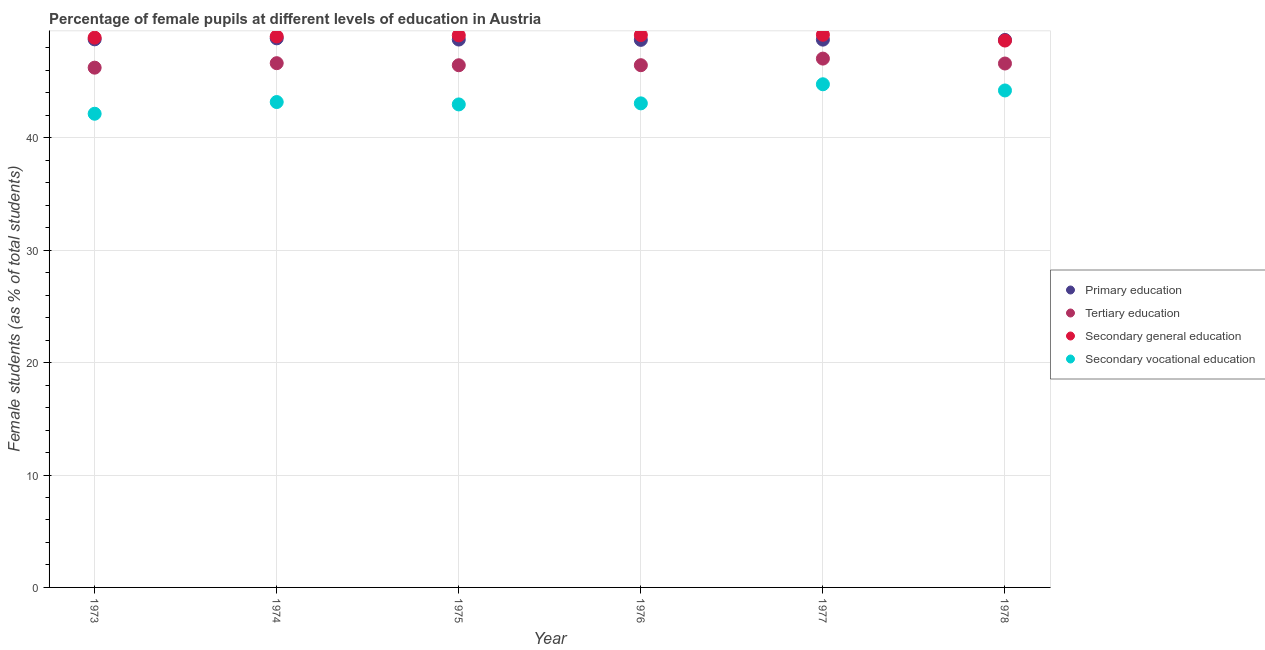How many different coloured dotlines are there?
Offer a very short reply. 4. Is the number of dotlines equal to the number of legend labels?
Your answer should be very brief. Yes. What is the percentage of female students in secondary education in 1975?
Provide a succinct answer. 49.11. Across all years, what is the maximum percentage of female students in secondary vocational education?
Provide a succinct answer. 44.76. Across all years, what is the minimum percentage of female students in secondary education?
Offer a very short reply. 48.65. In which year was the percentage of female students in primary education minimum?
Offer a very short reply. 1978. What is the total percentage of female students in tertiary education in the graph?
Offer a very short reply. 279.45. What is the difference between the percentage of female students in secondary vocational education in 1975 and that in 1977?
Ensure brevity in your answer.  -1.79. What is the difference between the percentage of female students in primary education in 1976 and the percentage of female students in secondary vocational education in 1977?
Provide a short and direct response. 3.95. What is the average percentage of female students in secondary vocational education per year?
Offer a very short reply. 43.39. In the year 1973, what is the difference between the percentage of female students in tertiary education and percentage of female students in primary education?
Keep it short and to the point. -2.52. What is the ratio of the percentage of female students in secondary education in 1973 to that in 1976?
Offer a terse response. 1. What is the difference between the highest and the second highest percentage of female students in secondary vocational education?
Provide a short and direct response. 0.55. What is the difference between the highest and the lowest percentage of female students in primary education?
Offer a terse response. 0.14. Is the sum of the percentage of female students in secondary education in 1974 and 1978 greater than the maximum percentage of female students in tertiary education across all years?
Keep it short and to the point. Yes. Is it the case that in every year, the sum of the percentage of female students in secondary vocational education and percentage of female students in secondary education is greater than the sum of percentage of female students in primary education and percentage of female students in tertiary education?
Make the answer very short. No. Is the percentage of female students in tertiary education strictly greater than the percentage of female students in primary education over the years?
Your answer should be compact. No. Is the percentage of female students in tertiary education strictly less than the percentage of female students in secondary education over the years?
Keep it short and to the point. Yes. How many years are there in the graph?
Your answer should be compact. 6. What is the difference between two consecutive major ticks on the Y-axis?
Your answer should be compact. 10. Are the values on the major ticks of Y-axis written in scientific E-notation?
Your answer should be very brief. No. Does the graph contain any zero values?
Give a very brief answer. No. Where does the legend appear in the graph?
Your answer should be very brief. Center right. How many legend labels are there?
Ensure brevity in your answer.  4. How are the legend labels stacked?
Give a very brief answer. Vertical. What is the title of the graph?
Keep it short and to the point. Percentage of female pupils at different levels of education in Austria. Does "Burnt food" appear as one of the legend labels in the graph?
Provide a succinct answer. No. What is the label or title of the X-axis?
Make the answer very short. Year. What is the label or title of the Y-axis?
Make the answer very short. Female students (as % of total students). What is the Female students (as % of total students) in Primary education in 1973?
Your answer should be compact. 48.76. What is the Female students (as % of total students) in Tertiary education in 1973?
Ensure brevity in your answer.  46.24. What is the Female students (as % of total students) in Secondary general education in 1973?
Your answer should be very brief. 48.91. What is the Female students (as % of total students) of Secondary vocational education in 1973?
Provide a short and direct response. 42.14. What is the Female students (as % of total students) of Primary education in 1974?
Your answer should be compact. 48.85. What is the Female students (as % of total students) in Tertiary education in 1974?
Provide a short and direct response. 46.64. What is the Female students (as % of total students) of Secondary general education in 1974?
Your answer should be compact. 49.02. What is the Female students (as % of total students) of Secondary vocational education in 1974?
Provide a succinct answer. 43.18. What is the Female students (as % of total students) of Primary education in 1975?
Make the answer very short. 48.74. What is the Female students (as % of total students) of Tertiary education in 1975?
Your response must be concise. 46.46. What is the Female students (as % of total students) of Secondary general education in 1975?
Your answer should be very brief. 49.11. What is the Female students (as % of total students) of Secondary vocational education in 1975?
Make the answer very short. 42.97. What is the Female students (as % of total students) of Primary education in 1976?
Offer a very short reply. 48.71. What is the Female students (as % of total students) in Tertiary education in 1976?
Make the answer very short. 46.46. What is the Female students (as % of total students) of Secondary general education in 1976?
Your response must be concise. 49.14. What is the Female students (as % of total students) of Secondary vocational education in 1976?
Make the answer very short. 43.06. What is the Female students (as % of total students) of Primary education in 1977?
Provide a succinct answer. 48.73. What is the Female students (as % of total students) in Tertiary education in 1977?
Your answer should be very brief. 47.05. What is the Female students (as % of total students) in Secondary general education in 1977?
Offer a terse response. 49.17. What is the Female students (as % of total students) of Secondary vocational education in 1977?
Offer a terse response. 44.76. What is the Female students (as % of total students) in Primary education in 1978?
Your answer should be compact. 48.71. What is the Female students (as % of total students) in Tertiary education in 1978?
Your response must be concise. 46.61. What is the Female students (as % of total students) in Secondary general education in 1978?
Give a very brief answer. 48.65. What is the Female students (as % of total students) of Secondary vocational education in 1978?
Make the answer very short. 44.21. Across all years, what is the maximum Female students (as % of total students) in Primary education?
Keep it short and to the point. 48.85. Across all years, what is the maximum Female students (as % of total students) in Tertiary education?
Ensure brevity in your answer.  47.05. Across all years, what is the maximum Female students (as % of total students) in Secondary general education?
Your answer should be compact. 49.17. Across all years, what is the maximum Female students (as % of total students) of Secondary vocational education?
Your response must be concise. 44.76. Across all years, what is the minimum Female students (as % of total students) of Primary education?
Your response must be concise. 48.71. Across all years, what is the minimum Female students (as % of total students) in Tertiary education?
Ensure brevity in your answer.  46.24. Across all years, what is the minimum Female students (as % of total students) in Secondary general education?
Your response must be concise. 48.65. Across all years, what is the minimum Female students (as % of total students) in Secondary vocational education?
Give a very brief answer. 42.14. What is the total Female students (as % of total students) in Primary education in the graph?
Offer a very short reply. 292.51. What is the total Female students (as % of total students) of Tertiary education in the graph?
Offer a very short reply. 279.45. What is the total Female students (as % of total students) in Secondary general education in the graph?
Your answer should be very brief. 294. What is the total Female students (as % of total students) in Secondary vocational education in the graph?
Your answer should be compact. 260.33. What is the difference between the Female students (as % of total students) in Primary education in 1973 and that in 1974?
Give a very brief answer. -0.09. What is the difference between the Female students (as % of total students) in Tertiary education in 1973 and that in 1974?
Your response must be concise. -0.4. What is the difference between the Female students (as % of total students) of Secondary general education in 1973 and that in 1974?
Your answer should be compact. -0.11. What is the difference between the Female students (as % of total students) in Secondary vocational education in 1973 and that in 1974?
Make the answer very short. -1.04. What is the difference between the Female students (as % of total students) in Primary education in 1973 and that in 1975?
Your answer should be compact. 0.02. What is the difference between the Female students (as % of total students) of Tertiary education in 1973 and that in 1975?
Your response must be concise. -0.22. What is the difference between the Female students (as % of total students) of Secondary general education in 1973 and that in 1975?
Ensure brevity in your answer.  -0.2. What is the difference between the Female students (as % of total students) of Secondary vocational education in 1973 and that in 1975?
Provide a short and direct response. -0.83. What is the difference between the Female students (as % of total students) of Primary education in 1973 and that in 1976?
Give a very brief answer. 0.05. What is the difference between the Female students (as % of total students) in Tertiary education in 1973 and that in 1976?
Offer a terse response. -0.22. What is the difference between the Female students (as % of total students) of Secondary general education in 1973 and that in 1976?
Your answer should be compact. -0.23. What is the difference between the Female students (as % of total students) in Secondary vocational education in 1973 and that in 1976?
Offer a terse response. -0.92. What is the difference between the Female students (as % of total students) of Primary education in 1973 and that in 1977?
Your answer should be very brief. 0.03. What is the difference between the Female students (as % of total students) in Tertiary education in 1973 and that in 1977?
Offer a very short reply. -0.81. What is the difference between the Female students (as % of total students) of Secondary general education in 1973 and that in 1977?
Ensure brevity in your answer.  -0.26. What is the difference between the Female students (as % of total students) in Secondary vocational education in 1973 and that in 1977?
Provide a succinct answer. -2.62. What is the difference between the Female students (as % of total students) of Primary education in 1973 and that in 1978?
Your answer should be very brief. 0.05. What is the difference between the Female students (as % of total students) of Tertiary education in 1973 and that in 1978?
Your response must be concise. -0.37. What is the difference between the Female students (as % of total students) of Secondary general education in 1973 and that in 1978?
Your answer should be compact. 0.26. What is the difference between the Female students (as % of total students) in Secondary vocational education in 1973 and that in 1978?
Provide a short and direct response. -2.07. What is the difference between the Female students (as % of total students) of Primary education in 1974 and that in 1975?
Keep it short and to the point. 0.11. What is the difference between the Female students (as % of total students) of Tertiary education in 1974 and that in 1975?
Your answer should be very brief. 0.18. What is the difference between the Female students (as % of total students) of Secondary general education in 1974 and that in 1975?
Your answer should be compact. -0.1. What is the difference between the Female students (as % of total students) of Secondary vocational education in 1974 and that in 1975?
Keep it short and to the point. 0.21. What is the difference between the Female students (as % of total students) of Primary education in 1974 and that in 1976?
Your answer should be very brief. 0.14. What is the difference between the Female students (as % of total students) of Tertiary education in 1974 and that in 1976?
Your answer should be compact. 0.18. What is the difference between the Female students (as % of total students) of Secondary general education in 1974 and that in 1976?
Your response must be concise. -0.12. What is the difference between the Female students (as % of total students) in Secondary vocational education in 1974 and that in 1976?
Provide a succinct answer. 0.12. What is the difference between the Female students (as % of total students) in Primary education in 1974 and that in 1977?
Keep it short and to the point. 0.12. What is the difference between the Female students (as % of total students) in Tertiary education in 1974 and that in 1977?
Keep it short and to the point. -0.41. What is the difference between the Female students (as % of total students) of Secondary general education in 1974 and that in 1977?
Give a very brief answer. -0.15. What is the difference between the Female students (as % of total students) of Secondary vocational education in 1974 and that in 1977?
Provide a short and direct response. -1.58. What is the difference between the Female students (as % of total students) of Primary education in 1974 and that in 1978?
Give a very brief answer. 0.14. What is the difference between the Female students (as % of total students) in Tertiary education in 1974 and that in 1978?
Provide a succinct answer. 0.03. What is the difference between the Female students (as % of total students) in Secondary general education in 1974 and that in 1978?
Provide a short and direct response. 0.36. What is the difference between the Female students (as % of total students) in Secondary vocational education in 1974 and that in 1978?
Your response must be concise. -1.03. What is the difference between the Female students (as % of total students) of Primary education in 1975 and that in 1976?
Keep it short and to the point. 0.03. What is the difference between the Female students (as % of total students) of Tertiary education in 1975 and that in 1976?
Your answer should be very brief. -0. What is the difference between the Female students (as % of total students) in Secondary general education in 1975 and that in 1976?
Offer a very short reply. -0.03. What is the difference between the Female students (as % of total students) in Secondary vocational education in 1975 and that in 1976?
Make the answer very short. -0.09. What is the difference between the Female students (as % of total students) in Primary education in 1975 and that in 1977?
Make the answer very short. 0.01. What is the difference between the Female students (as % of total students) in Tertiary education in 1975 and that in 1977?
Your answer should be very brief. -0.59. What is the difference between the Female students (as % of total students) in Secondary general education in 1975 and that in 1977?
Provide a short and direct response. -0.05. What is the difference between the Female students (as % of total students) in Secondary vocational education in 1975 and that in 1977?
Offer a terse response. -1.79. What is the difference between the Female students (as % of total students) of Primary education in 1975 and that in 1978?
Your answer should be compact. 0.03. What is the difference between the Female students (as % of total students) of Tertiary education in 1975 and that in 1978?
Offer a very short reply. -0.15. What is the difference between the Female students (as % of total students) of Secondary general education in 1975 and that in 1978?
Your response must be concise. 0.46. What is the difference between the Female students (as % of total students) in Secondary vocational education in 1975 and that in 1978?
Keep it short and to the point. -1.24. What is the difference between the Female students (as % of total students) of Primary education in 1976 and that in 1977?
Offer a terse response. -0.02. What is the difference between the Female students (as % of total students) in Tertiary education in 1976 and that in 1977?
Offer a terse response. -0.59. What is the difference between the Female students (as % of total students) in Secondary general education in 1976 and that in 1977?
Your answer should be very brief. -0.03. What is the difference between the Female students (as % of total students) of Secondary vocational education in 1976 and that in 1977?
Provide a short and direct response. -1.7. What is the difference between the Female students (as % of total students) in Primary education in 1976 and that in 1978?
Offer a terse response. 0.01. What is the difference between the Female students (as % of total students) of Tertiary education in 1976 and that in 1978?
Make the answer very short. -0.15. What is the difference between the Female students (as % of total students) of Secondary general education in 1976 and that in 1978?
Your response must be concise. 0.49. What is the difference between the Female students (as % of total students) in Secondary vocational education in 1976 and that in 1978?
Your answer should be very brief. -1.15. What is the difference between the Female students (as % of total students) in Primary education in 1977 and that in 1978?
Your answer should be very brief. 0.03. What is the difference between the Female students (as % of total students) of Tertiary education in 1977 and that in 1978?
Your answer should be compact. 0.44. What is the difference between the Female students (as % of total students) of Secondary general education in 1977 and that in 1978?
Offer a very short reply. 0.51. What is the difference between the Female students (as % of total students) of Secondary vocational education in 1977 and that in 1978?
Your response must be concise. 0.55. What is the difference between the Female students (as % of total students) of Primary education in 1973 and the Female students (as % of total students) of Tertiary education in 1974?
Ensure brevity in your answer.  2.12. What is the difference between the Female students (as % of total students) of Primary education in 1973 and the Female students (as % of total students) of Secondary general education in 1974?
Provide a succinct answer. -0.25. What is the difference between the Female students (as % of total students) of Primary education in 1973 and the Female students (as % of total students) of Secondary vocational education in 1974?
Your answer should be compact. 5.58. What is the difference between the Female students (as % of total students) in Tertiary education in 1973 and the Female students (as % of total students) in Secondary general education in 1974?
Offer a terse response. -2.77. What is the difference between the Female students (as % of total students) of Tertiary education in 1973 and the Female students (as % of total students) of Secondary vocational education in 1974?
Offer a terse response. 3.06. What is the difference between the Female students (as % of total students) of Secondary general education in 1973 and the Female students (as % of total students) of Secondary vocational education in 1974?
Provide a short and direct response. 5.73. What is the difference between the Female students (as % of total students) in Primary education in 1973 and the Female students (as % of total students) in Tertiary education in 1975?
Offer a terse response. 2.3. What is the difference between the Female students (as % of total students) in Primary education in 1973 and the Female students (as % of total students) in Secondary general education in 1975?
Make the answer very short. -0.35. What is the difference between the Female students (as % of total students) in Primary education in 1973 and the Female students (as % of total students) in Secondary vocational education in 1975?
Your answer should be compact. 5.79. What is the difference between the Female students (as % of total students) of Tertiary education in 1973 and the Female students (as % of total students) of Secondary general education in 1975?
Offer a terse response. -2.87. What is the difference between the Female students (as % of total students) in Tertiary education in 1973 and the Female students (as % of total students) in Secondary vocational education in 1975?
Ensure brevity in your answer.  3.27. What is the difference between the Female students (as % of total students) in Secondary general education in 1973 and the Female students (as % of total students) in Secondary vocational education in 1975?
Ensure brevity in your answer.  5.94. What is the difference between the Female students (as % of total students) of Primary education in 1973 and the Female students (as % of total students) of Tertiary education in 1976?
Give a very brief answer. 2.3. What is the difference between the Female students (as % of total students) in Primary education in 1973 and the Female students (as % of total students) in Secondary general education in 1976?
Ensure brevity in your answer.  -0.38. What is the difference between the Female students (as % of total students) in Primary education in 1973 and the Female students (as % of total students) in Secondary vocational education in 1976?
Offer a very short reply. 5.7. What is the difference between the Female students (as % of total students) in Tertiary education in 1973 and the Female students (as % of total students) in Secondary general education in 1976?
Your answer should be compact. -2.9. What is the difference between the Female students (as % of total students) of Tertiary education in 1973 and the Female students (as % of total students) of Secondary vocational education in 1976?
Your answer should be compact. 3.18. What is the difference between the Female students (as % of total students) in Secondary general education in 1973 and the Female students (as % of total students) in Secondary vocational education in 1976?
Give a very brief answer. 5.85. What is the difference between the Female students (as % of total students) in Primary education in 1973 and the Female students (as % of total students) in Tertiary education in 1977?
Your response must be concise. 1.71. What is the difference between the Female students (as % of total students) of Primary education in 1973 and the Female students (as % of total students) of Secondary general education in 1977?
Make the answer very short. -0.41. What is the difference between the Female students (as % of total students) in Primary education in 1973 and the Female students (as % of total students) in Secondary vocational education in 1977?
Provide a short and direct response. 4. What is the difference between the Female students (as % of total students) of Tertiary education in 1973 and the Female students (as % of total students) of Secondary general education in 1977?
Keep it short and to the point. -2.93. What is the difference between the Female students (as % of total students) in Tertiary education in 1973 and the Female students (as % of total students) in Secondary vocational education in 1977?
Your answer should be very brief. 1.48. What is the difference between the Female students (as % of total students) of Secondary general education in 1973 and the Female students (as % of total students) of Secondary vocational education in 1977?
Ensure brevity in your answer.  4.15. What is the difference between the Female students (as % of total students) in Primary education in 1973 and the Female students (as % of total students) in Tertiary education in 1978?
Provide a succinct answer. 2.15. What is the difference between the Female students (as % of total students) of Primary education in 1973 and the Female students (as % of total students) of Secondary general education in 1978?
Provide a succinct answer. 0.11. What is the difference between the Female students (as % of total students) of Primary education in 1973 and the Female students (as % of total students) of Secondary vocational education in 1978?
Provide a short and direct response. 4.55. What is the difference between the Female students (as % of total students) of Tertiary education in 1973 and the Female students (as % of total students) of Secondary general education in 1978?
Give a very brief answer. -2.41. What is the difference between the Female students (as % of total students) of Tertiary education in 1973 and the Female students (as % of total students) of Secondary vocational education in 1978?
Give a very brief answer. 2.03. What is the difference between the Female students (as % of total students) of Secondary general education in 1973 and the Female students (as % of total students) of Secondary vocational education in 1978?
Offer a terse response. 4.7. What is the difference between the Female students (as % of total students) of Primary education in 1974 and the Female students (as % of total students) of Tertiary education in 1975?
Keep it short and to the point. 2.39. What is the difference between the Female students (as % of total students) in Primary education in 1974 and the Female students (as % of total students) in Secondary general education in 1975?
Your answer should be very brief. -0.26. What is the difference between the Female students (as % of total students) of Primary education in 1974 and the Female students (as % of total students) of Secondary vocational education in 1975?
Your response must be concise. 5.88. What is the difference between the Female students (as % of total students) in Tertiary education in 1974 and the Female students (as % of total students) in Secondary general education in 1975?
Your response must be concise. -2.47. What is the difference between the Female students (as % of total students) of Tertiary education in 1974 and the Female students (as % of total students) of Secondary vocational education in 1975?
Ensure brevity in your answer.  3.67. What is the difference between the Female students (as % of total students) of Secondary general education in 1974 and the Female students (as % of total students) of Secondary vocational education in 1975?
Keep it short and to the point. 6.04. What is the difference between the Female students (as % of total students) in Primary education in 1974 and the Female students (as % of total students) in Tertiary education in 1976?
Ensure brevity in your answer.  2.39. What is the difference between the Female students (as % of total students) in Primary education in 1974 and the Female students (as % of total students) in Secondary general education in 1976?
Make the answer very short. -0.29. What is the difference between the Female students (as % of total students) in Primary education in 1974 and the Female students (as % of total students) in Secondary vocational education in 1976?
Your answer should be compact. 5.79. What is the difference between the Female students (as % of total students) of Tertiary education in 1974 and the Female students (as % of total students) of Secondary general education in 1976?
Give a very brief answer. -2.5. What is the difference between the Female students (as % of total students) of Tertiary education in 1974 and the Female students (as % of total students) of Secondary vocational education in 1976?
Offer a terse response. 3.58. What is the difference between the Female students (as % of total students) in Secondary general education in 1974 and the Female students (as % of total students) in Secondary vocational education in 1976?
Your answer should be very brief. 5.95. What is the difference between the Female students (as % of total students) in Primary education in 1974 and the Female students (as % of total students) in Tertiary education in 1977?
Offer a very short reply. 1.8. What is the difference between the Female students (as % of total students) of Primary education in 1974 and the Female students (as % of total students) of Secondary general education in 1977?
Your answer should be compact. -0.32. What is the difference between the Female students (as % of total students) of Primary education in 1974 and the Female students (as % of total students) of Secondary vocational education in 1977?
Your response must be concise. 4.09. What is the difference between the Female students (as % of total students) in Tertiary education in 1974 and the Female students (as % of total students) in Secondary general education in 1977?
Your answer should be very brief. -2.53. What is the difference between the Female students (as % of total students) in Tertiary education in 1974 and the Female students (as % of total students) in Secondary vocational education in 1977?
Your response must be concise. 1.88. What is the difference between the Female students (as % of total students) of Secondary general education in 1974 and the Female students (as % of total students) of Secondary vocational education in 1977?
Make the answer very short. 4.25. What is the difference between the Female students (as % of total students) of Primary education in 1974 and the Female students (as % of total students) of Tertiary education in 1978?
Your answer should be very brief. 2.24. What is the difference between the Female students (as % of total students) in Primary education in 1974 and the Female students (as % of total students) in Secondary general education in 1978?
Provide a succinct answer. 0.2. What is the difference between the Female students (as % of total students) in Primary education in 1974 and the Female students (as % of total students) in Secondary vocational education in 1978?
Keep it short and to the point. 4.64. What is the difference between the Female students (as % of total students) in Tertiary education in 1974 and the Female students (as % of total students) in Secondary general education in 1978?
Your answer should be compact. -2.01. What is the difference between the Female students (as % of total students) in Tertiary education in 1974 and the Female students (as % of total students) in Secondary vocational education in 1978?
Offer a terse response. 2.43. What is the difference between the Female students (as % of total students) of Secondary general education in 1974 and the Female students (as % of total students) of Secondary vocational education in 1978?
Provide a succinct answer. 4.8. What is the difference between the Female students (as % of total students) in Primary education in 1975 and the Female students (as % of total students) in Tertiary education in 1976?
Your answer should be very brief. 2.28. What is the difference between the Female students (as % of total students) in Primary education in 1975 and the Female students (as % of total students) in Secondary general education in 1976?
Provide a succinct answer. -0.4. What is the difference between the Female students (as % of total students) in Primary education in 1975 and the Female students (as % of total students) in Secondary vocational education in 1976?
Give a very brief answer. 5.68. What is the difference between the Female students (as % of total students) in Tertiary education in 1975 and the Female students (as % of total students) in Secondary general education in 1976?
Give a very brief answer. -2.68. What is the difference between the Female students (as % of total students) in Tertiary education in 1975 and the Female students (as % of total students) in Secondary vocational education in 1976?
Ensure brevity in your answer.  3.39. What is the difference between the Female students (as % of total students) of Secondary general education in 1975 and the Female students (as % of total students) of Secondary vocational education in 1976?
Keep it short and to the point. 6.05. What is the difference between the Female students (as % of total students) in Primary education in 1975 and the Female students (as % of total students) in Tertiary education in 1977?
Offer a terse response. 1.69. What is the difference between the Female students (as % of total students) in Primary education in 1975 and the Female students (as % of total students) in Secondary general education in 1977?
Ensure brevity in your answer.  -0.43. What is the difference between the Female students (as % of total students) in Primary education in 1975 and the Female students (as % of total students) in Secondary vocational education in 1977?
Offer a terse response. 3.98. What is the difference between the Female students (as % of total students) in Tertiary education in 1975 and the Female students (as % of total students) in Secondary general education in 1977?
Provide a succinct answer. -2.71. What is the difference between the Female students (as % of total students) of Tertiary education in 1975 and the Female students (as % of total students) of Secondary vocational education in 1977?
Provide a succinct answer. 1.69. What is the difference between the Female students (as % of total students) in Secondary general education in 1975 and the Female students (as % of total students) in Secondary vocational education in 1977?
Ensure brevity in your answer.  4.35. What is the difference between the Female students (as % of total students) in Primary education in 1975 and the Female students (as % of total students) in Tertiary education in 1978?
Your response must be concise. 2.13. What is the difference between the Female students (as % of total students) in Primary education in 1975 and the Female students (as % of total students) in Secondary general education in 1978?
Provide a succinct answer. 0.09. What is the difference between the Female students (as % of total students) of Primary education in 1975 and the Female students (as % of total students) of Secondary vocational education in 1978?
Offer a very short reply. 4.53. What is the difference between the Female students (as % of total students) of Tertiary education in 1975 and the Female students (as % of total students) of Secondary general education in 1978?
Provide a short and direct response. -2.2. What is the difference between the Female students (as % of total students) of Tertiary education in 1975 and the Female students (as % of total students) of Secondary vocational education in 1978?
Your response must be concise. 2.24. What is the difference between the Female students (as % of total students) in Secondary general education in 1975 and the Female students (as % of total students) in Secondary vocational education in 1978?
Offer a very short reply. 4.9. What is the difference between the Female students (as % of total students) in Primary education in 1976 and the Female students (as % of total students) in Tertiary education in 1977?
Keep it short and to the point. 1.67. What is the difference between the Female students (as % of total students) in Primary education in 1976 and the Female students (as % of total students) in Secondary general education in 1977?
Ensure brevity in your answer.  -0.45. What is the difference between the Female students (as % of total students) in Primary education in 1976 and the Female students (as % of total students) in Secondary vocational education in 1977?
Provide a short and direct response. 3.95. What is the difference between the Female students (as % of total students) of Tertiary education in 1976 and the Female students (as % of total students) of Secondary general education in 1977?
Provide a succinct answer. -2.71. What is the difference between the Female students (as % of total students) in Tertiary education in 1976 and the Female students (as % of total students) in Secondary vocational education in 1977?
Offer a very short reply. 1.7. What is the difference between the Female students (as % of total students) of Secondary general education in 1976 and the Female students (as % of total students) of Secondary vocational education in 1977?
Give a very brief answer. 4.38. What is the difference between the Female students (as % of total students) of Primary education in 1976 and the Female students (as % of total students) of Tertiary education in 1978?
Your answer should be very brief. 2.1. What is the difference between the Female students (as % of total students) in Primary education in 1976 and the Female students (as % of total students) in Secondary general education in 1978?
Offer a terse response. 0.06. What is the difference between the Female students (as % of total students) of Primary education in 1976 and the Female students (as % of total students) of Secondary vocational education in 1978?
Make the answer very short. 4.5. What is the difference between the Female students (as % of total students) in Tertiary education in 1976 and the Female students (as % of total students) in Secondary general education in 1978?
Provide a short and direct response. -2.19. What is the difference between the Female students (as % of total students) of Tertiary education in 1976 and the Female students (as % of total students) of Secondary vocational education in 1978?
Ensure brevity in your answer.  2.25. What is the difference between the Female students (as % of total students) of Secondary general education in 1976 and the Female students (as % of total students) of Secondary vocational education in 1978?
Provide a short and direct response. 4.93. What is the difference between the Female students (as % of total students) in Primary education in 1977 and the Female students (as % of total students) in Tertiary education in 1978?
Make the answer very short. 2.12. What is the difference between the Female students (as % of total students) in Primary education in 1977 and the Female students (as % of total students) in Secondary general education in 1978?
Your response must be concise. 0.08. What is the difference between the Female students (as % of total students) of Primary education in 1977 and the Female students (as % of total students) of Secondary vocational education in 1978?
Give a very brief answer. 4.52. What is the difference between the Female students (as % of total students) in Tertiary education in 1977 and the Female students (as % of total students) in Secondary general education in 1978?
Ensure brevity in your answer.  -1.61. What is the difference between the Female students (as % of total students) in Tertiary education in 1977 and the Female students (as % of total students) in Secondary vocational education in 1978?
Provide a succinct answer. 2.83. What is the difference between the Female students (as % of total students) in Secondary general education in 1977 and the Female students (as % of total students) in Secondary vocational education in 1978?
Offer a terse response. 4.95. What is the average Female students (as % of total students) of Primary education per year?
Keep it short and to the point. 48.75. What is the average Female students (as % of total students) in Tertiary education per year?
Your answer should be compact. 46.58. What is the average Female students (as % of total students) of Secondary general education per year?
Your answer should be very brief. 49. What is the average Female students (as % of total students) of Secondary vocational education per year?
Give a very brief answer. 43.39. In the year 1973, what is the difference between the Female students (as % of total students) of Primary education and Female students (as % of total students) of Tertiary education?
Your answer should be very brief. 2.52. In the year 1973, what is the difference between the Female students (as % of total students) of Primary education and Female students (as % of total students) of Secondary general education?
Give a very brief answer. -0.15. In the year 1973, what is the difference between the Female students (as % of total students) of Primary education and Female students (as % of total students) of Secondary vocational education?
Offer a very short reply. 6.62. In the year 1973, what is the difference between the Female students (as % of total students) of Tertiary education and Female students (as % of total students) of Secondary general education?
Make the answer very short. -2.67. In the year 1973, what is the difference between the Female students (as % of total students) of Tertiary education and Female students (as % of total students) of Secondary vocational education?
Ensure brevity in your answer.  4.1. In the year 1973, what is the difference between the Female students (as % of total students) of Secondary general education and Female students (as % of total students) of Secondary vocational education?
Make the answer very short. 6.77. In the year 1974, what is the difference between the Female students (as % of total students) of Primary education and Female students (as % of total students) of Tertiary education?
Provide a short and direct response. 2.21. In the year 1974, what is the difference between the Female students (as % of total students) of Primary education and Female students (as % of total students) of Secondary general education?
Your answer should be compact. -0.17. In the year 1974, what is the difference between the Female students (as % of total students) in Primary education and Female students (as % of total students) in Secondary vocational education?
Give a very brief answer. 5.67. In the year 1974, what is the difference between the Female students (as % of total students) in Tertiary education and Female students (as % of total students) in Secondary general education?
Ensure brevity in your answer.  -2.38. In the year 1974, what is the difference between the Female students (as % of total students) of Tertiary education and Female students (as % of total students) of Secondary vocational education?
Your answer should be very brief. 3.46. In the year 1974, what is the difference between the Female students (as % of total students) of Secondary general education and Female students (as % of total students) of Secondary vocational education?
Provide a short and direct response. 5.83. In the year 1975, what is the difference between the Female students (as % of total students) in Primary education and Female students (as % of total students) in Tertiary education?
Offer a terse response. 2.29. In the year 1975, what is the difference between the Female students (as % of total students) in Primary education and Female students (as % of total students) in Secondary general education?
Keep it short and to the point. -0.37. In the year 1975, what is the difference between the Female students (as % of total students) of Primary education and Female students (as % of total students) of Secondary vocational education?
Keep it short and to the point. 5.77. In the year 1975, what is the difference between the Female students (as % of total students) of Tertiary education and Female students (as % of total students) of Secondary general education?
Offer a very short reply. -2.66. In the year 1975, what is the difference between the Female students (as % of total students) of Tertiary education and Female students (as % of total students) of Secondary vocational education?
Offer a very short reply. 3.49. In the year 1975, what is the difference between the Female students (as % of total students) in Secondary general education and Female students (as % of total students) in Secondary vocational education?
Your response must be concise. 6.14. In the year 1976, what is the difference between the Female students (as % of total students) in Primary education and Female students (as % of total students) in Tertiary education?
Offer a very short reply. 2.25. In the year 1976, what is the difference between the Female students (as % of total students) in Primary education and Female students (as % of total students) in Secondary general education?
Your response must be concise. -0.43. In the year 1976, what is the difference between the Female students (as % of total students) in Primary education and Female students (as % of total students) in Secondary vocational education?
Offer a terse response. 5.65. In the year 1976, what is the difference between the Female students (as % of total students) of Tertiary education and Female students (as % of total students) of Secondary general education?
Ensure brevity in your answer.  -2.68. In the year 1976, what is the difference between the Female students (as % of total students) in Tertiary education and Female students (as % of total students) in Secondary vocational education?
Offer a terse response. 3.4. In the year 1976, what is the difference between the Female students (as % of total students) of Secondary general education and Female students (as % of total students) of Secondary vocational education?
Your answer should be very brief. 6.08. In the year 1977, what is the difference between the Female students (as % of total students) of Primary education and Female students (as % of total students) of Tertiary education?
Keep it short and to the point. 1.69. In the year 1977, what is the difference between the Female students (as % of total students) in Primary education and Female students (as % of total students) in Secondary general education?
Give a very brief answer. -0.43. In the year 1977, what is the difference between the Female students (as % of total students) in Primary education and Female students (as % of total students) in Secondary vocational education?
Ensure brevity in your answer.  3.97. In the year 1977, what is the difference between the Female students (as % of total students) of Tertiary education and Female students (as % of total students) of Secondary general education?
Your answer should be very brief. -2.12. In the year 1977, what is the difference between the Female students (as % of total students) of Tertiary education and Female students (as % of total students) of Secondary vocational education?
Ensure brevity in your answer.  2.28. In the year 1977, what is the difference between the Female students (as % of total students) of Secondary general education and Female students (as % of total students) of Secondary vocational education?
Offer a very short reply. 4.4. In the year 1978, what is the difference between the Female students (as % of total students) in Primary education and Female students (as % of total students) in Tertiary education?
Make the answer very short. 2.1. In the year 1978, what is the difference between the Female students (as % of total students) in Primary education and Female students (as % of total students) in Secondary general education?
Your answer should be compact. 0.06. In the year 1978, what is the difference between the Female students (as % of total students) of Primary education and Female students (as % of total students) of Secondary vocational education?
Offer a very short reply. 4.5. In the year 1978, what is the difference between the Female students (as % of total students) in Tertiary education and Female students (as % of total students) in Secondary general education?
Keep it short and to the point. -2.04. In the year 1978, what is the difference between the Female students (as % of total students) in Tertiary education and Female students (as % of total students) in Secondary vocational education?
Provide a short and direct response. 2.4. In the year 1978, what is the difference between the Female students (as % of total students) of Secondary general education and Female students (as % of total students) of Secondary vocational education?
Provide a succinct answer. 4.44. What is the ratio of the Female students (as % of total students) of Primary education in 1973 to that in 1974?
Your answer should be very brief. 1. What is the ratio of the Female students (as % of total students) in Secondary general education in 1973 to that in 1974?
Your answer should be compact. 1. What is the ratio of the Female students (as % of total students) in Secondary vocational education in 1973 to that in 1974?
Provide a succinct answer. 0.98. What is the ratio of the Female students (as % of total students) of Primary education in 1973 to that in 1975?
Your response must be concise. 1. What is the ratio of the Female students (as % of total students) in Tertiary education in 1973 to that in 1975?
Offer a very short reply. 1. What is the ratio of the Female students (as % of total students) of Secondary general education in 1973 to that in 1975?
Your answer should be very brief. 1. What is the ratio of the Female students (as % of total students) in Secondary vocational education in 1973 to that in 1975?
Keep it short and to the point. 0.98. What is the ratio of the Female students (as % of total students) in Primary education in 1973 to that in 1976?
Your answer should be compact. 1. What is the ratio of the Female students (as % of total students) in Tertiary education in 1973 to that in 1976?
Offer a terse response. 1. What is the ratio of the Female students (as % of total students) of Secondary general education in 1973 to that in 1976?
Provide a short and direct response. 1. What is the ratio of the Female students (as % of total students) in Secondary vocational education in 1973 to that in 1976?
Your answer should be very brief. 0.98. What is the ratio of the Female students (as % of total students) of Primary education in 1973 to that in 1977?
Offer a terse response. 1. What is the ratio of the Female students (as % of total students) of Tertiary education in 1973 to that in 1977?
Your answer should be very brief. 0.98. What is the ratio of the Female students (as % of total students) of Secondary general education in 1973 to that in 1977?
Ensure brevity in your answer.  0.99. What is the ratio of the Female students (as % of total students) of Secondary vocational education in 1973 to that in 1977?
Offer a very short reply. 0.94. What is the ratio of the Female students (as % of total students) of Tertiary education in 1973 to that in 1978?
Offer a terse response. 0.99. What is the ratio of the Female students (as % of total students) in Secondary general education in 1973 to that in 1978?
Keep it short and to the point. 1.01. What is the ratio of the Female students (as % of total students) of Secondary vocational education in 1973 to that in 1978?
Offer a terse response. 0.95. What is the ratio of the Female students (as % of total students) of Primary education in 1974 to that in 1975?
Your response must be concise. 1. What is the ratio of the Female students (as % of total students) in Tertiary education in 1974 to that in 1975?
Provide a short and direct response. 1. What is the ratio of the Female students (as % of total students) of Secondary vocational education in 1974 to that in 1975?
Offer a very short reply. 1. What is the ratio of the Female students (as % of total students) of Primary education in 1974 to that in 1976?
Your answer should be very brief. 1. What is the ratio of the Female students (as % of total students) in Tertiary education in 1974 to that in 1976?
Provide a short and direct response. 1. What is the ratio of the Female students (as % of total students) in Secondary general education in 1974 to that in 1976?
Give a very brief answer. 1. What is the ratio of the Female students (as % of total students) in Primary education in 1974 to that in 1977?
Ensure brevity in your answer.  1. What is the ratio of the Female students (as % of total students) of Secondary vocational education in 1974 to that in 1977?
Provide a succinct answer. 0.96. What is the ratio of the Female students (as % of total students) of Primary education in 1974 to that in 1978?
Offer a very short reply. 1. What is the ratio of the Female students (as % of total students) in Tertiary education in 1974 to that in 1978?
Make the answer very short. 1. What is the ratio of the Female students (as % of total students) of Secondary general education in 1974 to that in 1978?
Your answer should be compact. 1.01. What is the ratio of the Female students (as % of total students) of Secondary vocational education in 1974 to that in 1978?
Offer a terse response. 0.98. What is the ratio of the Female students (as % of total students) of Secondary general education in 1975 to that in 1976?
Ensure brevity in your answer.  1. What is the ratio of the Female students (as % of total students) of Secondary vocational education in 1975 to that in 1976?
Keep it short and to the point. 1. What is the ratio of the Female students (as % of total students) of Tertiary education in 1975 to that in 1977?
Offer a very short reply. 0.99. What is the ratio of the Female students (as % of total students) of Secondary vocational education in 1975 to that in 1977?
Provide a succinct answer. 0.96. What is the ratio of the Female students (as % of total students) of Tertiary education in 1975 to that in 1978?
Offer a terse response. 1. What is the ratio of the Female students (as % of total students) of Secondary general education in 1975 to that in 1978?
Offer a terse response. 1.01. What is the ratio of the Female students (as % of total students) in Secondary vocational education in 1975 to that in 1978?
Provide a short and direct response. 0.97. What is the ratio of the Female students (as % of total students) in Primary education in 1976 to that in 1977?
Your answer should be compact. 1. What is the ratio of the Female students (as % of total students) in Tertiary education in 1976 to that in 1977?
Offer a terse response. 0.99. What is the ratio of the Female students (as % of total students) in Secondary vocational education in 1976 to that in 1977?
Provide a short and direct response. 0.96. What is the ratio of the Female students (as % of total students) in Secondary general education in 1976 to that in 1978?
Provide a short and direct response. 1.01. What is the ratio of the Female students (as % of total students) in Secondary vocational education in 1976 to that in 1978?
Offer a terse response. 0.97. What is the ratio of the Female students (as % of total students) of Tertiary education in 1977 to that in 1978?
Your answer should be compact. 1.01. What is the ratio of the Female students (as % of total students) of Secondary general education in 1977 to that in 1978?
Your answer should be very brief. 1.01. What is the ratio of the Female students (as % of total students) of Secondary vocational education in 1977 to that in 1978?
Make the answer very short. 1.01. What is the difference between the highest and the second highest Female students (as % of total students) of Primary education?
Make the answer very short. 0.09. What is the difference between the highest and the second highest Female students (as % of total students) in Tertiary education?
Offer a terse response. 0.41. What is the difference between the highest and the second highest Female students (as % of total students) in Secondary general education?
Your answer should be compact. 0.03. What is the difference between the highest and the second highest Female students (as % of total students) in Secondary vocational education?
Keep it short and to the point. 0.55. What is the difference between the highest and the lowest Female students (as % of total students) in Primary education?
Your answer should be compact. 0.14. What is the difference between the highest and the lowest Female students (as % of total students) of Tertiary education?
Ensure brevity in your answer.  0.81. What is the difference between the highest and the lowest Female students (as % of total students) in Secondary general education?
Your answer should be very brief. 0.51. What is the difference between the highest and the lowest Female students (as % of total students) of Secondary vocational education?
Provide a short and direct response. 2.62. 